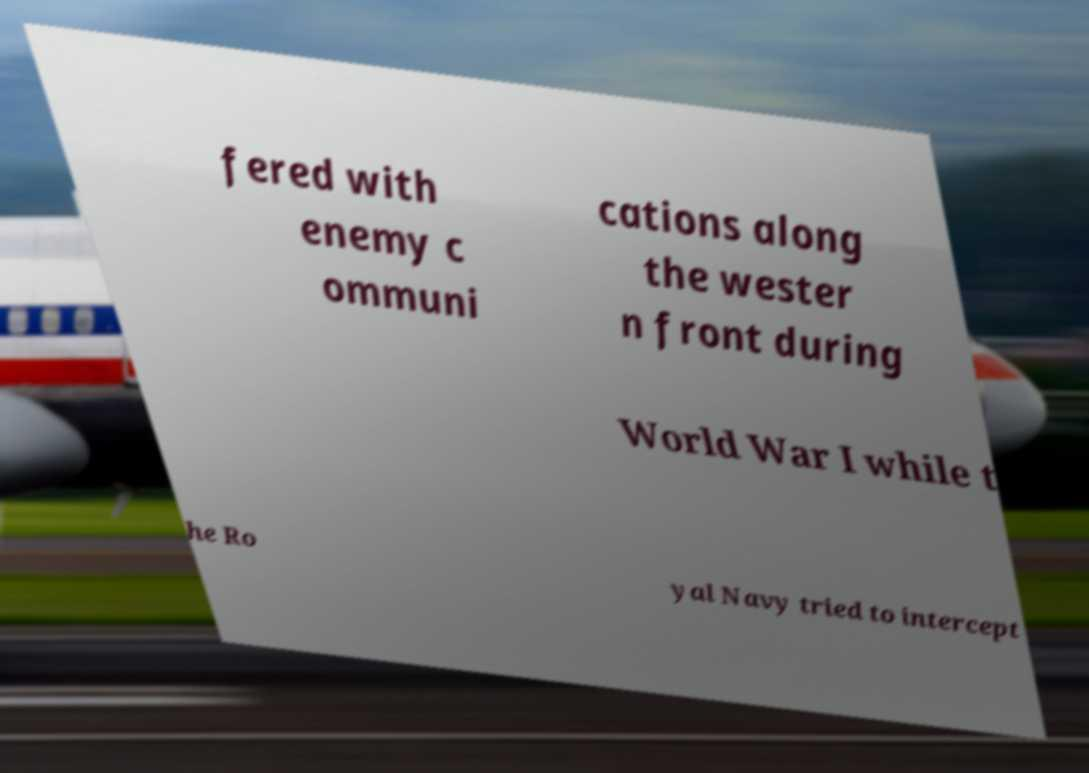Can you accurately transcribe the text from the provided image for me? fered with enemy c ommuni cations along the wester n front during World War I while t he Ro yal Navy tried to intercept 